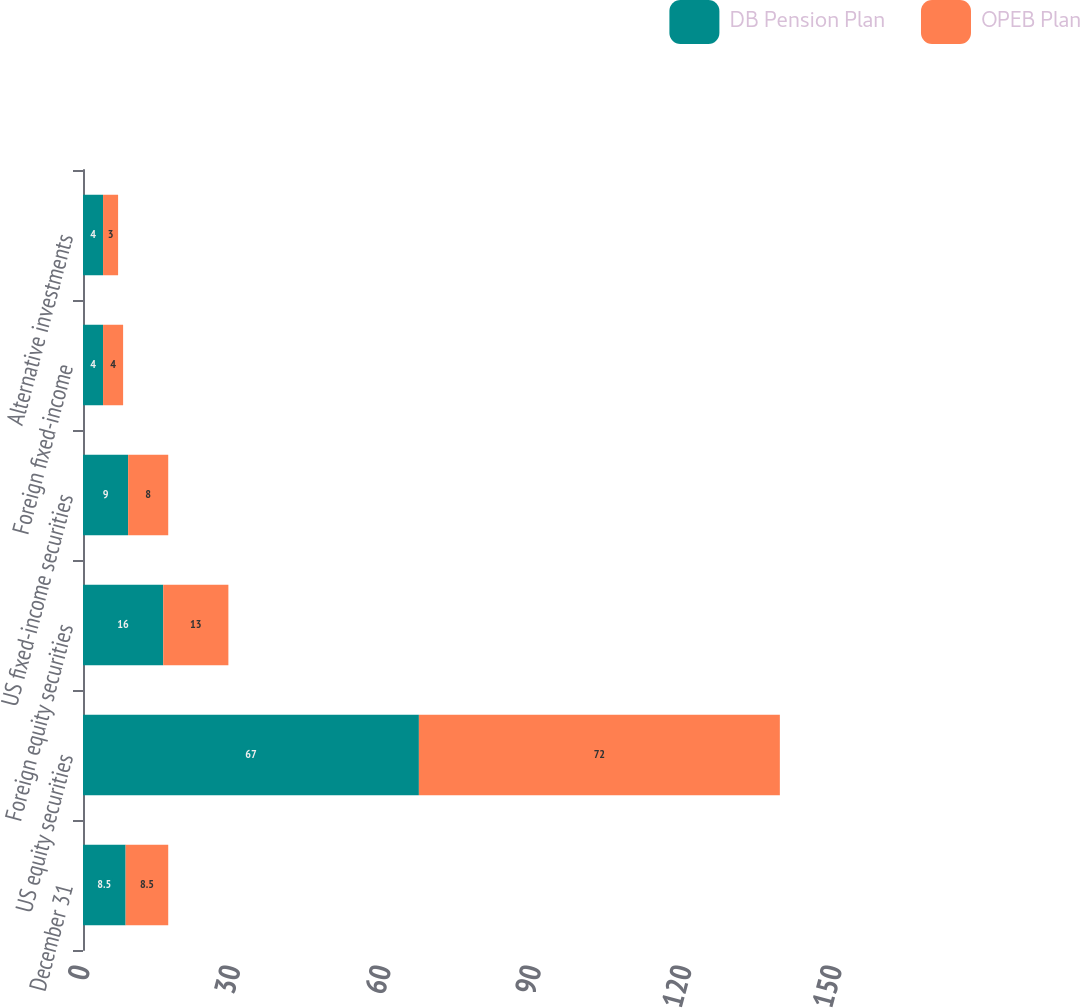Convert chart to OTSL. <chart><loc_0><loc_0><loc_500><loc_500><stacked_bar_chart><ecel><fcel>December 31<fcel>US equity securities<fcel>Foreign equity securities<fcel>US fixed-income securities<fcel>Foreign fixed-income<fcel>Alternative investments<nl><fcel>DB Pension Plan<fcel>8.5<fcel>67<fcel>16<fcel>9<fcel>4<fcel>4<nl><fcel>OPEB Plan<fcel>8.5<fcel>72<fcel>13<fcel>8<fcel>4<fcel>3<nl></chart> 